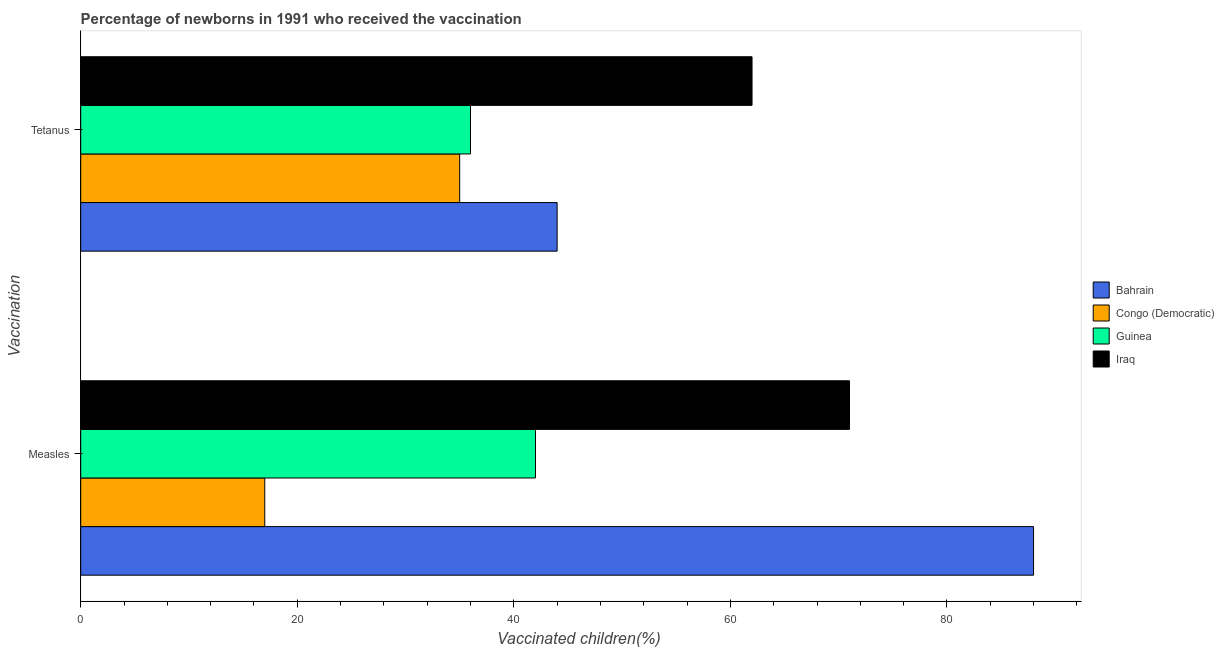How many groups of bars are there?
Provide a succinct answer. 2. Are the number of bars per tick equal to the number of legend labels?
Offer a terse response. Yes. Are the number of bars on each tick of the Y-axis equal?
Offer a very short reply. Yes. How many bars are there on the 1st tick from the top?
Offer a very short reply. 4. How many bars are there on the 1st tick from the bottom?
Offer a very short reply. 4. What is the label of the 2nd group of bars from the top?
Your answer should be very brief. Measles. What is the percentage of newborns who received vaccination for measles in Guinea?
Your answer should be compact. 42. Across all countries, what is the maximum percentage of newborns who received vaccination for measles?
Offer a very short reply. 88. Across all countries, what is the minimum percentage of newborns who received vaccination for measles?
Your answer should be very brief. 17. In which country was the percentage of newborns who received vaccination for measles maximum?
Keep it short and to the point. Bahrain. In which country was the percentage of newborns who received vaccination for tetanus minimum?
Give a very brief answer. Congo (Democratic). What is the total percentage of newborns who received vaccination for measles in the graph?
Your answer should be compact. 218. What is the difference between the percentage of newborns who received vaccination for tetanus in Guinea and that in Congo (Democratic)?
Ensure brevity in your answer.  1. What is the difference between the percentage of newborns who received vaccination for tetanus in Guinea and the percentage of newborns who received vaccination for measles in Bahrain?
Ensure brevity in your answer.  -52. What is the average percentage of newborns who received vaccination for tetanus per country?
Your answer should be very brief. 44.25. What is the difference between the percentage of newborns who received vaccination for tetanus and percentage of newborns who received vaccination for measles in Iraq?
Your answer should be compact. -9. What is the ratio of the percentage of newborns who received vaccination for tetanus in Bahrain to that in Guinea?
Provide a succinct answer. 1.22. Is the percentage of newborns who received vaccination for measles in Congo (Democratic) less than that in Guinea?
Give a very brief answer. Yes. In how many countries, is the percentage of newborns who received vaccination for tetanus greater than the average percentage of newborns who received vaccination for tetanus taken over all countries?
Provide a short and direct response. 1. What does the 2nd bar from the top in Tetanus represents?
Make the answer very short. Guinea. What does the 4th bar from the bottom in Tetanus represents?
Your response must be concise. Iraq. How many bars are there?
Provide a succinct answer. 8. How many countries are there in the graph?
Keep it short and to the point. 4. Are the values on the major ticks of X-axis written in scientific E-notation?
Ensure brevity in your answer.  No. Where does the legend appear in the graph?
Your response must be concise. Center right. What is the title of the graph?
Ensure brevity in your answer.  Percentage of newborns in 1991 who received the vaccination. What is the label or title of the X-axis?
Provide a succinct answer. Vaccinated children(%)
. What is the label or title of the Y-axis?
Ensure brevity in your answer.  Vaccination. What is the Vaccinated children(%)
 of Bahrain in Measles?
Keep it short and to the point. 88. What is the Vaccinated children(%)
 of Congo (Democratic) in Measles?
Your answer should be compact. 17. What is the Vaccinated children(%)
 of Guinea in Measles?
Your answer should be compact. 42. What is the Vaccinated children(%)
 in Bahrain in Tetanus?
Provide a short and direct response. 44. Across all Vaccination, what is the maximum Vaccinated children(%)
 in Iraq?
Provide a succinct answer. 71. Across all Vaccination, what is the minimum Vaccinated children(%)
 in Bahrain?
Your answer should be very brief. 44. Across all Vaccination, what is the minimum Vaccinated children(%)
 of Congo (Democratic)?
Your answer should be very brief. 17. What is the total Vaccinated children(%)
 of Bahrain in the graph?
Your answer should be very brief. 132. What is the total Vaccinated children(%)
 of Congo (Democratic) in the graph?
Provide a short and direct response. 52. What is the total Vaccinated children(%)
 in Guinea in the graph?
Your answer should be very brief. 78. What is the total Vaccinated children(%)
 in Iraq in the graph?
Make the answer very short. 133. What is the difference between the Vaccinated children(%)
 of Congo (Democratic) in Measles and that in Tetanus?
Ensure brevity in your answer.  -18. What is the difference between the Vaccinated children(%)
 of Guinea in Measles and that in Tetanus?
Your answer should be compact. 6. What is the difference between the Vaccinated children(%)
 in Bahrain in Measles and the Vaccinated children(%)
 in Congo (Democratic) in Tetanus?
Your answer should be compact. 53. What is the difference between the Vaccinated children(%)
 of Bahrain in Measles and the Vaccinated children(%)
 of Iraq in Tetanus?
Give a very brief answer. 26. What is the difference between the Vaccinated children(%)
 of Congo (Democratic) in Measles and the Vaccinated children(%)
 of Guinea in Tetanus?
Provide a succinct answer. -19. What is the difference between the Vaccinated children(%)
 in Congo (Democratic) in Measles and the Vaccinated children(%)
 in Iraq in Tetanus?
Your answer should be very brief. -45. What is the difference between the Vaccinated children(%)
 in Guinea in Measles and the Vaccinated children(%)
 in Iraq in Tetanus?
Keep it short and to the point. -20. What is the average Vaccinated children(%)
 in Congo (Democratic) per Vaccination?
Make the answer very short. 26. What is the average Vaccinated children(%)
 in Guinea per Vaccination?
Offer a terse response. 39. What is the average Vaccinated children(%)
 in Iraq per Vaccination?
Provide a short and direct response. 66.5. What is the difference between the Vaccinated children(%)
 of Bahrain and Vaccinated children(%)
 of Guinea in Measles?
Offer a very short reply. 46. What is the difference between the Vaccinated children(%)
 of Congo (Democratic) and Vaccinated children(%)
 of Iraq in Measles?
Make the answer very short. -54. What is the difference between the Vaccinated children(%)
 in Guinea and Vaccinated children(%)
 in Iraq in Measles?
Provide a short and direct response. -29. What is the difference between the Vaccinated children(%)
 of Bahrain and Vaccinated children(%)
 of Iraq in Tetanus?
Offer a terse response. -18. What is the difference between the Vaccinated children(%)
 in Congo (Democratic) and Vaccinated children(%)
 in Iraq in Tetanus?
Ensure brevity in your answer.  -27. What is the ratio of the Vaccinated children(%)
 of Bahrain in Measles to that in Tetanus?
Ensure brevity in your answer.  2. What is the ratio of the Vaccinated children(%)
 in Congo (Democratic) in Measles to that in Tetanus?
Offer a very short reply. 0.49. What is the ratio of the Vaccinated children(%)
 of Guinea in Measles to that in Tetanus?
Your answer should be very brief. 1.17. What is the ratio of the Vaccinated children(%)
 of Iraq in Measles to that in Tetanus?
Offer a terse response. 1.15. What is the difference between the highest and the second highest Vaccinated children(%)
 in Guinea?
Your answer should be very brief. 6. What is the difference between the highest and the lowest Vaccinated children(%)
 of Bahrain?
Offer a very short reply. 44. What is the difference between the highest and the lowest Vaccinated children(%)
 of Iraq?
Give a very brief answer. 9. 